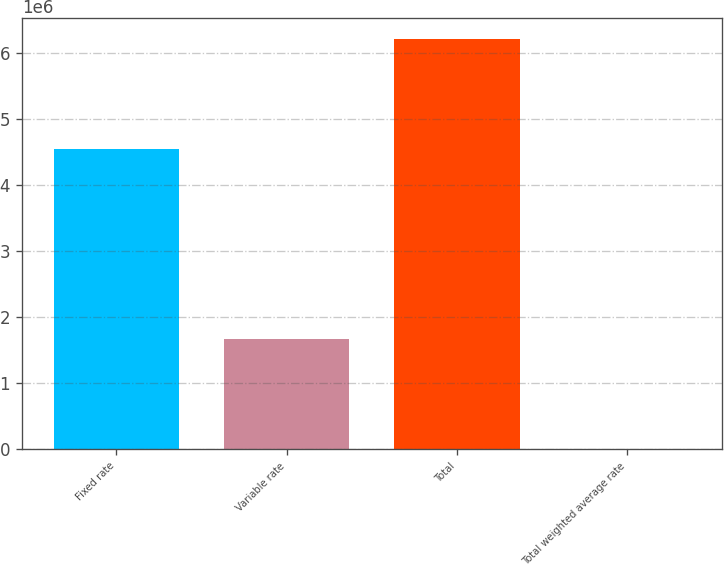Convert chart to OTSL. <chart><loc_0><loc_0><loc_500><loc_500><bar_chart><fcel>Fixed rate<fcel>Variable rate<fcel>Total<fcel>Total weighted average rate<nl><fcel>4.54124e+06<fcel>1.66903e+06<fcel>6.21027e+06<fcel>5.97<nl></chart> 